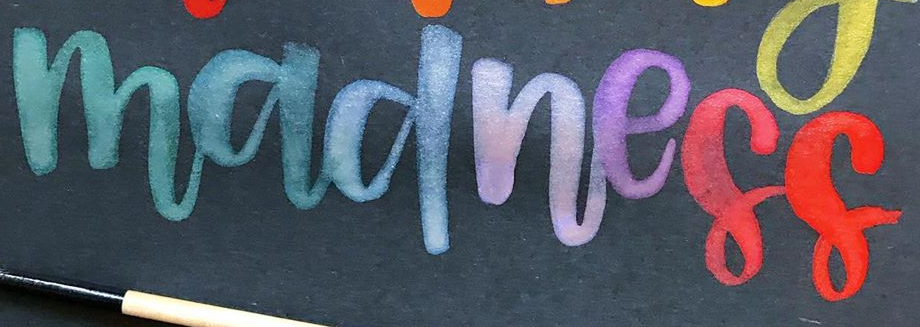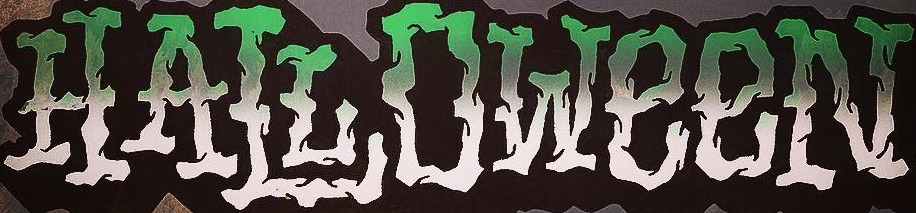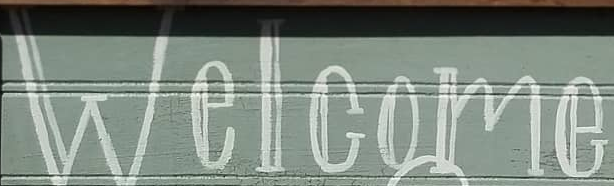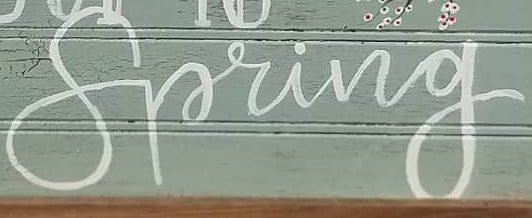Identify the words shown in these images in order, separated by a semicolon. madness; HALLOWeeN; Welcome; Spring 